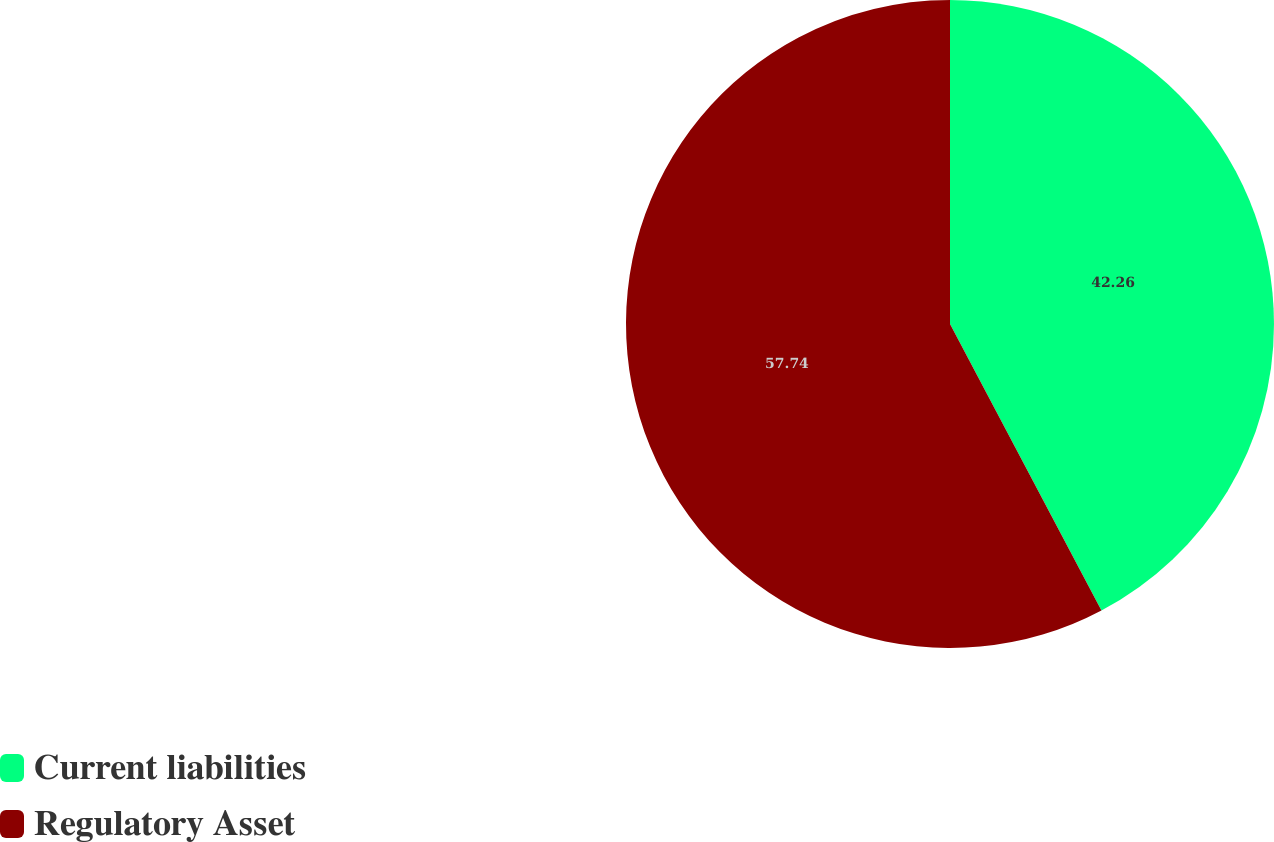Convert chart. <chart><loc_0><loc_0><loc_500><loc_500><pie_chart><fcel>Current liabilities<fcel>Regulatory Asset<nl><fcel>42.26%<fcel>57.74%<nl></chart> 